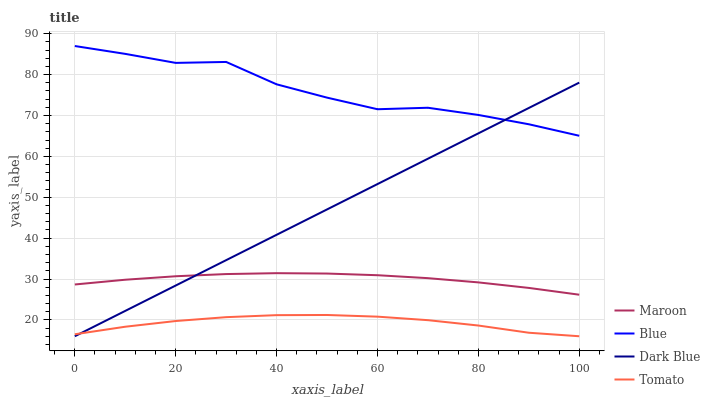Does Tomato have the minimum area under the curve?
Answer yes or no. Yes. Does Blue have the maximum area under the curve?
Answer yes or no. Yes. Does Dark Blue have the minimum area under the curve?
Answer yes or no. No. Does Dark Blue have the maximum area under the curve?
Answer yes or no. No. Is Dark Blue the smoothest?
Answer yes or no. Yes. Is Blue the roughest?
Answer yes or no. Yes. Is Tomato the smoothest?
Answer yes or no. No. Is Tomato the roughest?
Answer yes or no. No. Does Dark Blue have the lowest value?
Answer yes or no. Yes. Does Maroon have the lowest value?
Answer yes or no. No. Does Blue have the highest value?
Answer yes or no. Yes. Does Dark Blue have the highest value?
Answer yes or no. No. Is Tomato less than Maroon?
Answer yes or no. Yes. Is Blue greater than Maroon?
Answer yes or no. Yes. Does Dark Blue intersect Maroon?
Answer yes or no. Yes. Is Dark Blue less than Maroon?
Answer yes or no. No. Is Dark Blue greater than Maroon?
Answer yes or no. No. Does Tomato intersect Maroon?
Answer yes or no. No. 